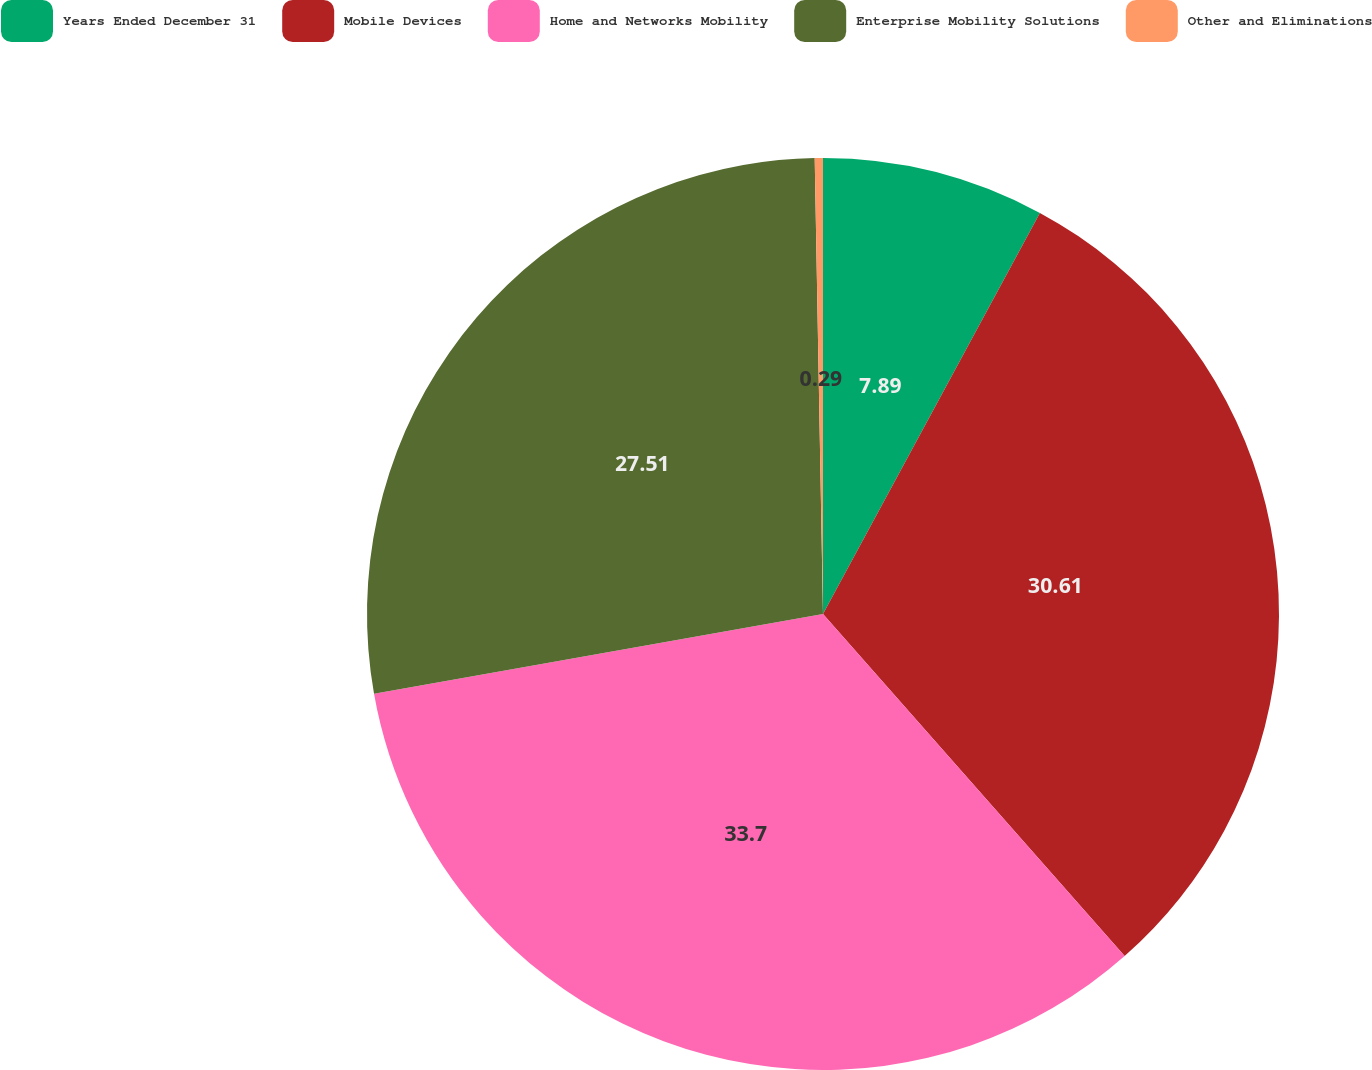<chart> <loc_0><loc_0><loc_500><loc_500><pie_chart><fcel>Years Ended December 31<fcel>Mobile Devices<fcel>Home and Networks Mobility<fcel>Enterprise Mobility Solutions<fcel>Other and Eliminations<nl><fcel>7.89%<fcel>30.61%<fcel>33.71%<fcel>27.51%<fcel>0.29%<nl></chart> 